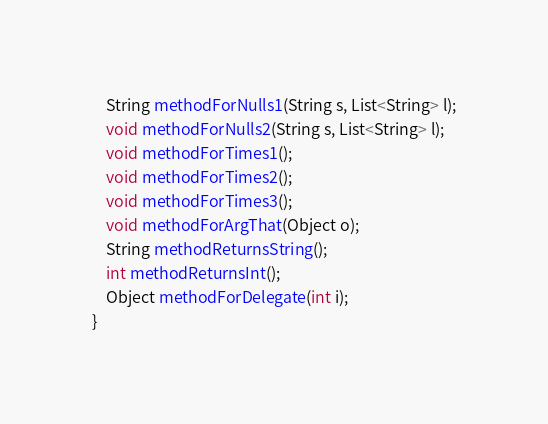Convert code to text. <code><loc_0><loc_0><loc_500><loc_500><_Java_>    String methodForNulls1(String s, List<String> l);
    void methodForNulls2(String s, List<String> l);
    void methodForTimes1();
    void methodForTimes2();
    void methodForTimes3();
    void methodForArgThat(Object o);
    String methodReturnsString();
    int methodReturnsInt();
    Object methodForDelegate(int i);
}
</code> 